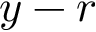<formula> <loc_0><loc_0><loc_500><loc_500>y - r</formula> 